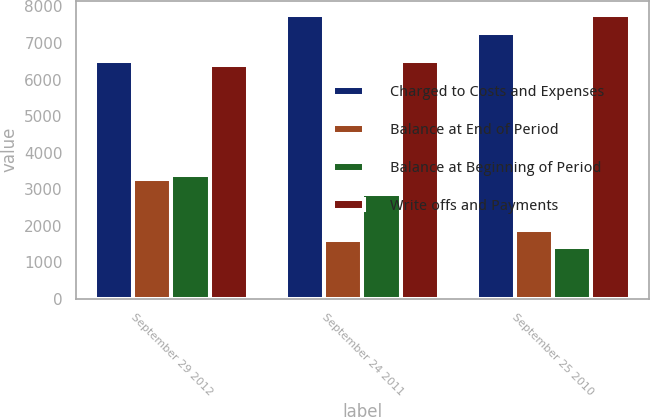<chart> <loc_0><loc_0><loc_500><loc_500><stacked_bar_chart><ecel><fcel>September 29 2012<fcel>September 24 2011<fcel>September 25 2010<nl><fcel>Charged to Costs and Expenses<fcel>6516<fcel>7769<fcel>7279<nl><fcel>Balance at End of Period<fcel>3270<fcel>1614<fcel>1895<nl><fcel>Balance at Beginning of Period<fcel>3390<fcel>2867<fcel>1405<nl><fcel>Write offs and Payments<fcel>6396<fcel>6516<fcel>7769<nl></chart> 